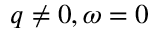<formula> <loc_0><loc_0><loc_500><loc_500>q \neq 0 , \omega = 0</formula> 